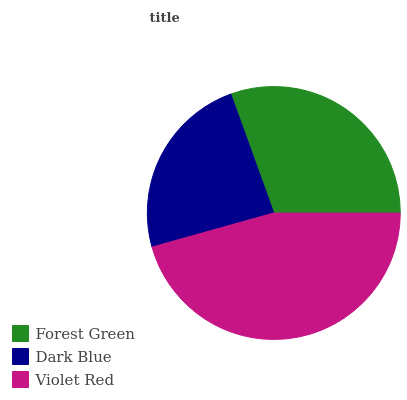Is Dark Blue the minimum?
Answer yes or no. Yes. Is Violet Red the maximum?
Answer yes or no. Yes. Is Violet Red the minimum?
Answer yes or no. No. Is Dark Blue the maximum?
Answer yes or no. No. Is Violet Red greater than Dark Blue?
Answer yes or no. Yes. Is Dark Blue less than Violet Red?
Answer yes or no. Yes. Is Dark Blue greater than Violet Red?
Answer yes or no. No. Is Violet Red less than Dark Blue?
Answer yes or no. No. Is Forest Green the high median?
Answer yes or no. Yes. Is Forest Green the low median?
Answer yes or no. Yes. Is Violet Red the high median?
Answer yes or no. No. Is Dark Blue the low median?
Answer yes or no. No. 